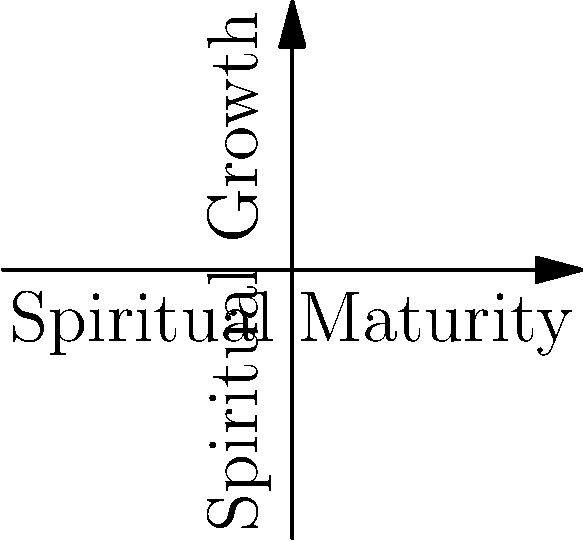In the context of spiritual formation, identify the four stages represented by the blue dots on the "Active Growth" curve, and explain how they relate to the overall process of spiritual maturity. To answer this question, let's examine the graph and its components:

1. The x-axis represents "Spiritual Maturity," while the y-axis represents "Spiritual Growth."

2. The blue curve represents "Active Growth" in spiritual formation.

3. There are four blue dots on the curve, each representing a distinct stage in spiritual formation.

4. The stages, in order from left to right, are:

   a) Awakening: This is the initial stage where an individual becomes aware of their spiritual journey and begins to seek a deeper connection with the divine.
   
   b) Purgation: In this stage, the individual undergoes a process of cleansing and purification, addressing personal shortcomings and sin.
   
   c) Illumination: This stage involves gaining spiritual insight and a deeper understanding of divine truths.
   
   d) Union: The final stage represents a profound connection with the divine, characterized by a sense of oneness and complete surrender.

5. The curve shows that growth is not linear but accelerates as one progresses through the stages, indicating that spiritual maturity leads to more rapid spiritual growth.

6. The red curve represents plateaus in spiritual growth, suggesting that the journey is not always one of constant progress but may include periods of apparent stagnation.

These stages form a comprehensive model of spiritual formation, illustrating the progression from initial awareness to complete union with the divine. Each stage builds upon the previous one, contributing to overall spiritual maturity and growth.
Answer: Awakening, Purgation, Illumination, Union 